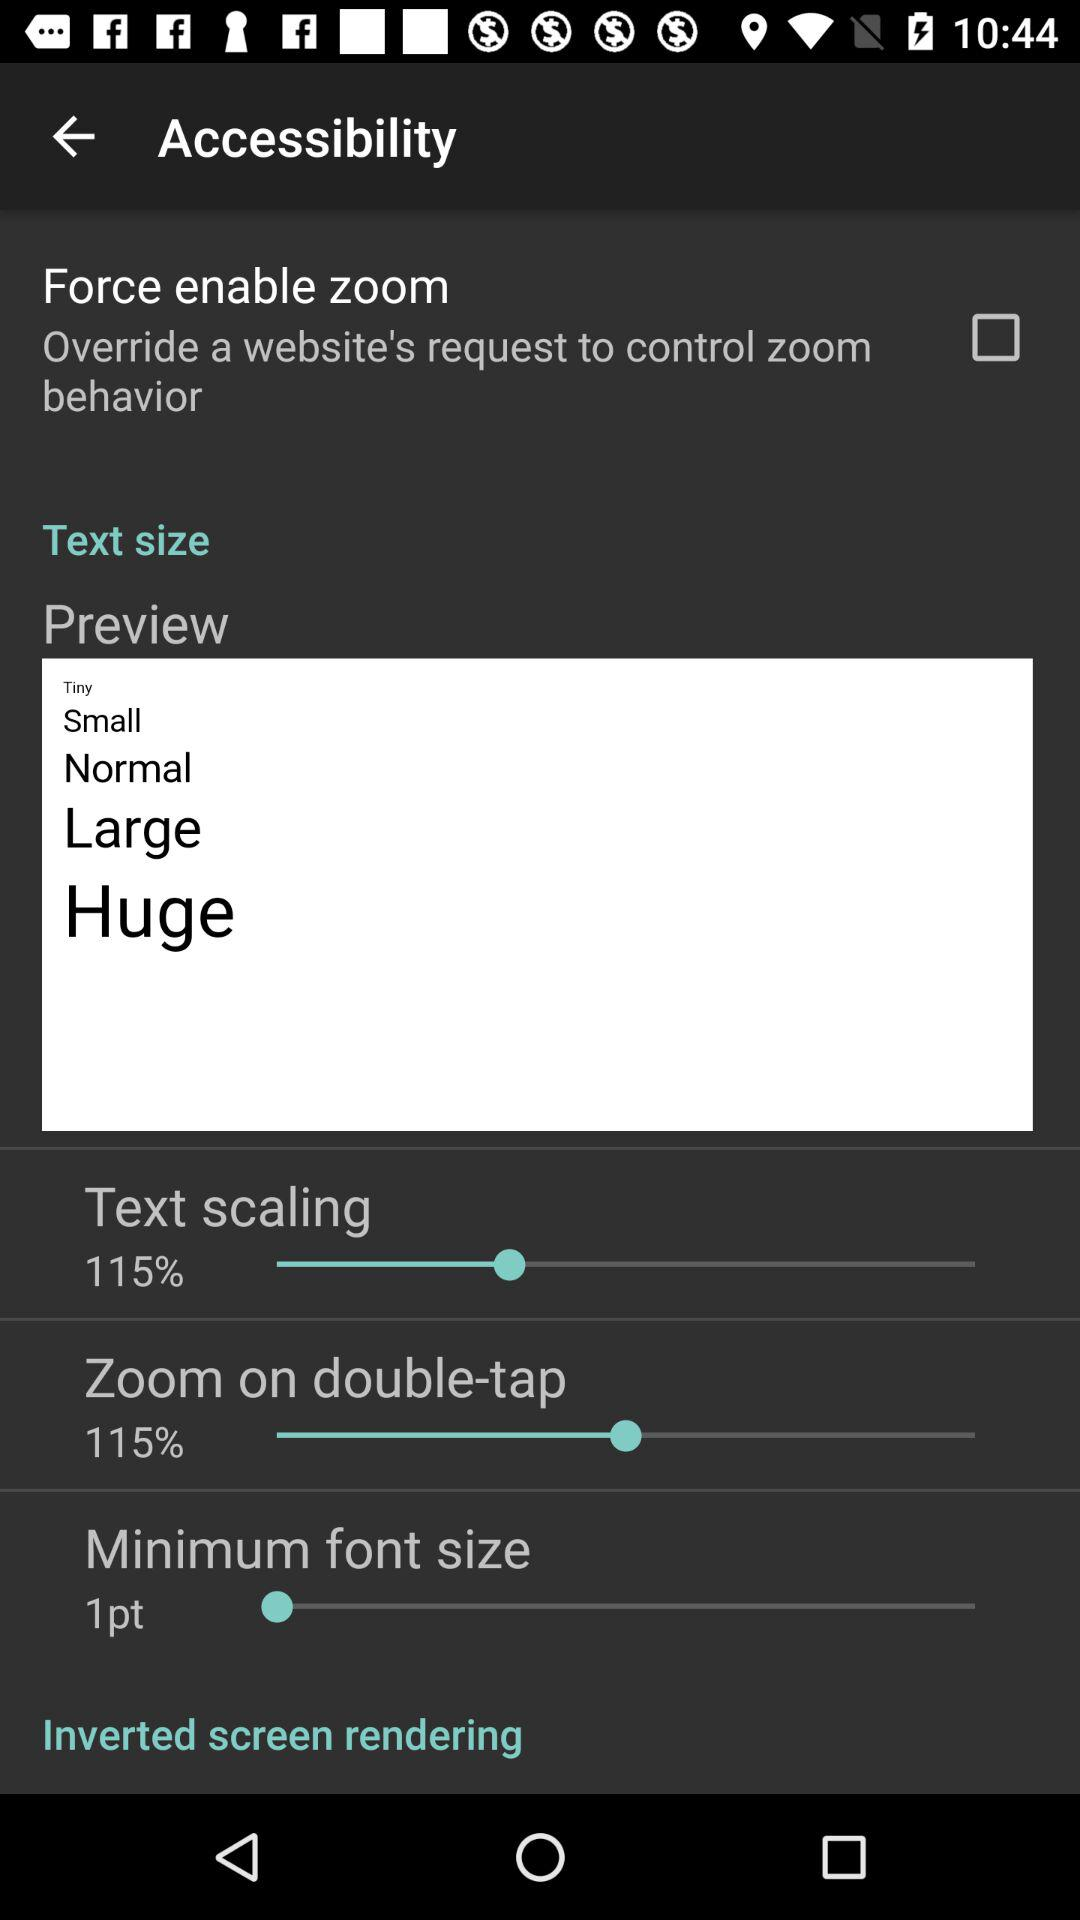What are the options for text size? The options for text size are "Tiny", "Small", "Normal", "Large" and "Huge". 